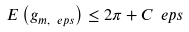<formula> <loc_0><loc_0><loc_500><loc_500>E \left ( g _ { m , \ e p s } \right ) \leq 2 \pi + C \ e p s</formula> 